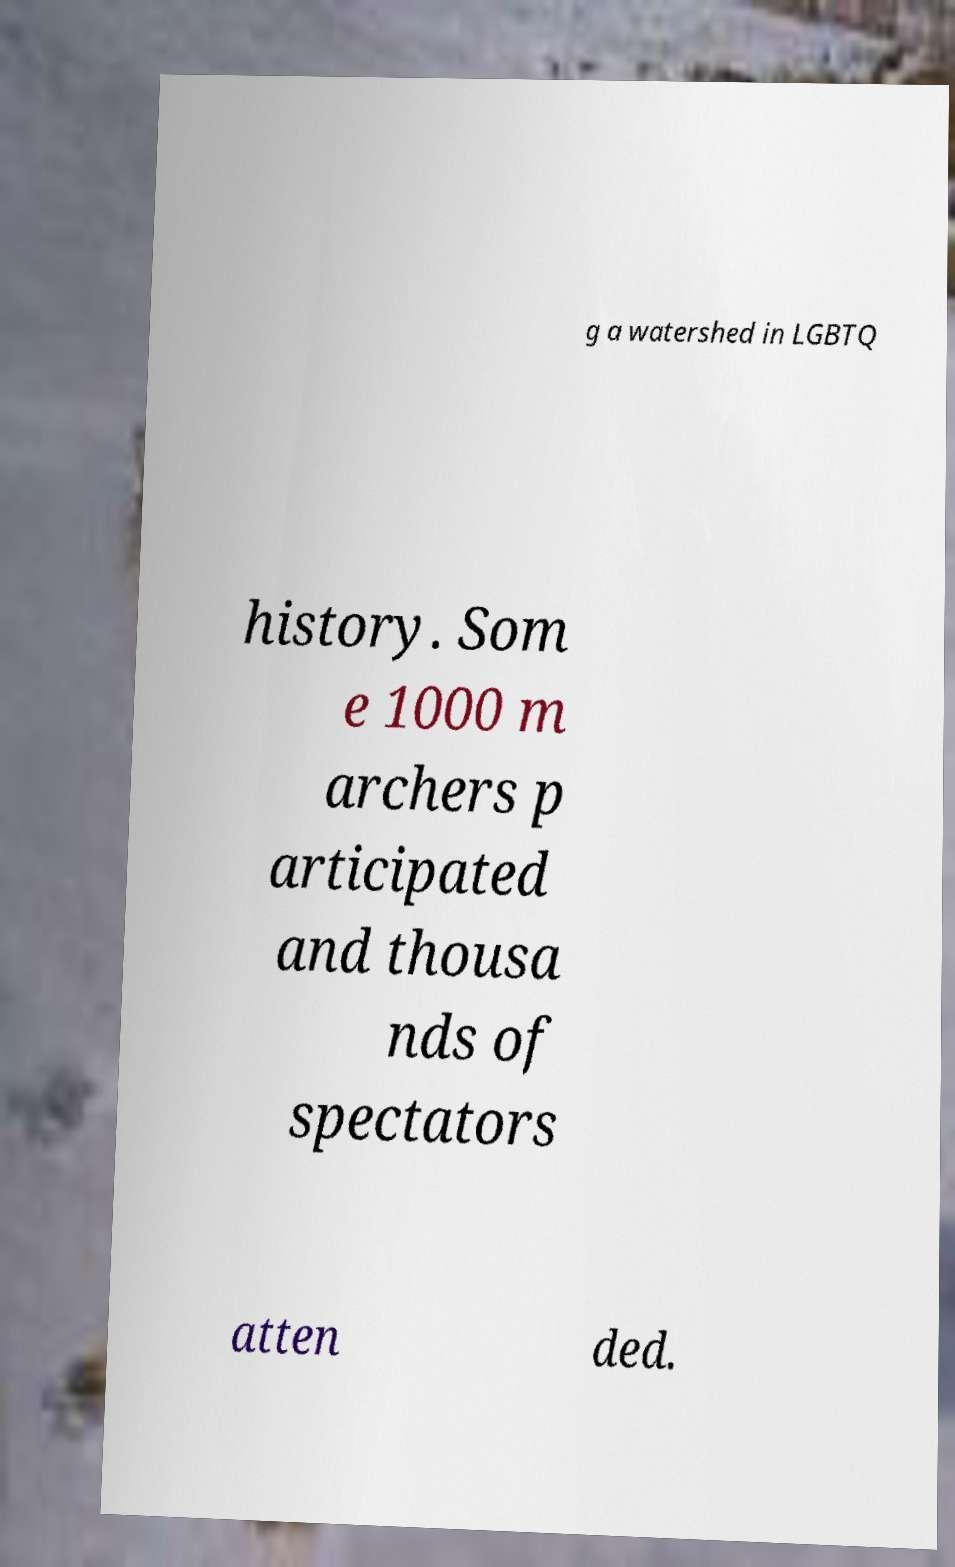Can you accurately transcribe the text from the provided image for me? g a watershed in LGBTQ history. Som e 1000 m archers p articipated and thousa nds of spectators atten ded. 